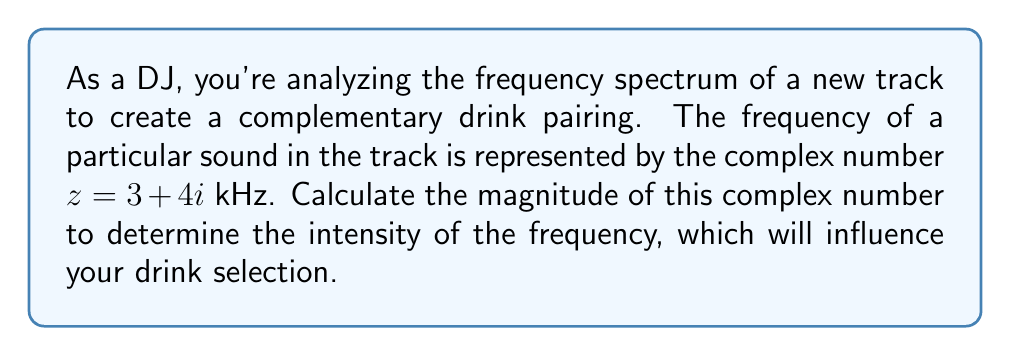Give your solution to this math problem. To find the magnitude of a complex number $z = a + bi$, we use the formula:

$$|z| = \sqrt{a^2 + b^2}$$

For the given complex number $z = 3 + 4i$:

1) Identify the real and imaginary parts:
   $a = 3$ and $b = 4$

2) Square both parts:
   $a^2 = 3^2 = 9$
   $b^2 = 4^2 = 16$

3) Add the squared terms:
   $a^2 + b^2 = 9 + 16 = 25$

4) Take the square root of the sum:
   $|z| = \sqrt{25} = 5$

Therefore, the magnitude of the complex number $3 + 4i$ is 5 kHz.
Answer: $5$ kHz 